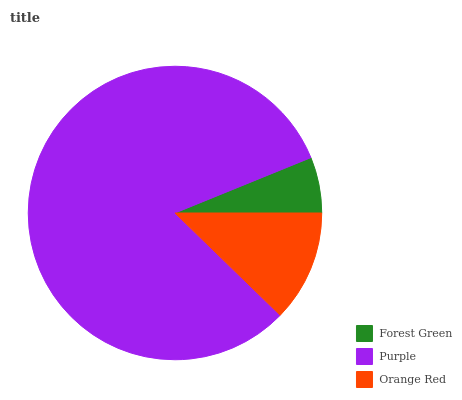Is Forest Green the minimum?
Answer yes or no. Yes. Is Purple the maximum?
Answer yes or no. Yes. Is Orange Red the minimum?
Answer yes or no. No. Is Orange Red the maximum?
Answer yes or no. No. Is Purple greater than Orange Red?
Answer yes or no. Yes. Is Orange Red less than Purple?
Answer yes or no. Yes. Is Orange Red greater than Purple?
Answer yes or no. No. Is Purple less than Orange Red?
Answer yes or no. No. Is Orange Red the high median?
Answer yes or no. Yes. Is Orange Red the low median?
Answer yes or no. Yes. Is Purple the high median?
Answer yes or no. No. Is Purple the low median?
Answer yes or no. No. 